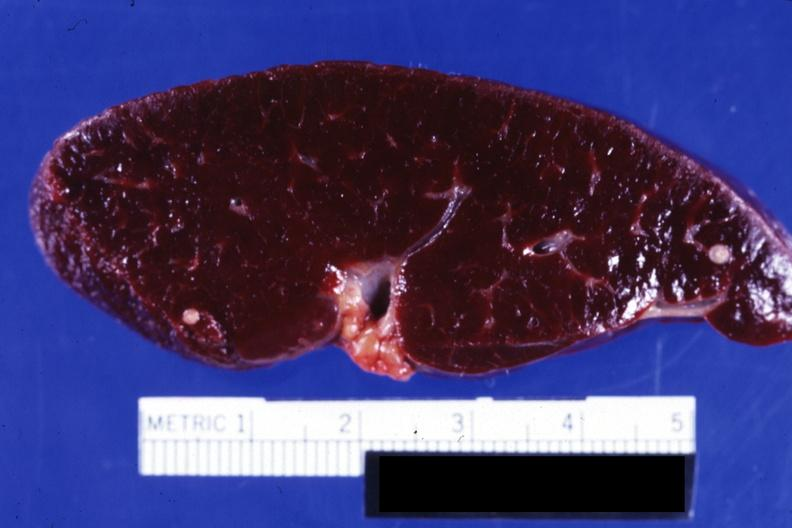what is present?
Answer the question using a single word or phrase. Hematologic 